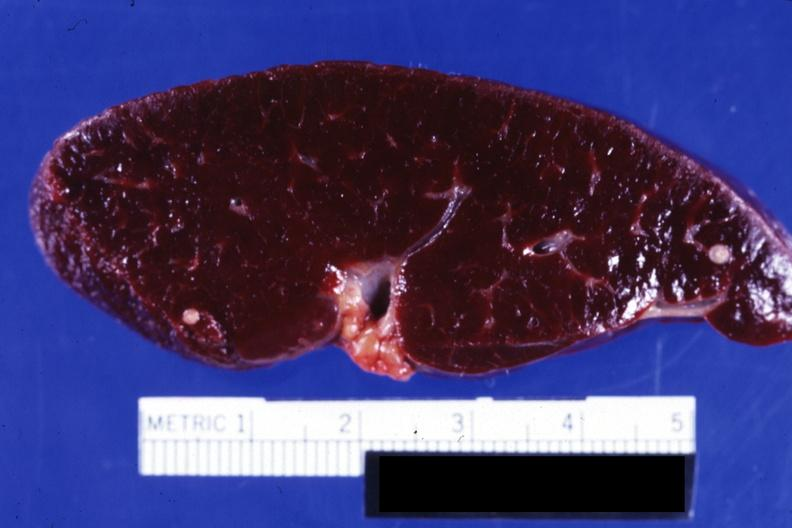what is present?
Answer the question using a single word or phrase. Hematologic 